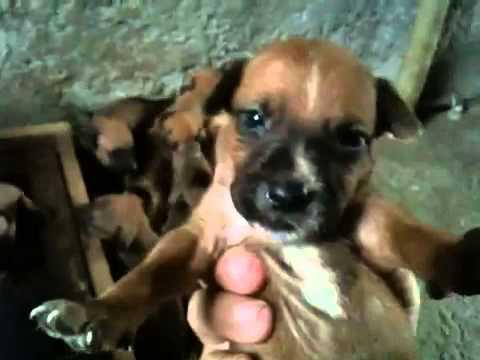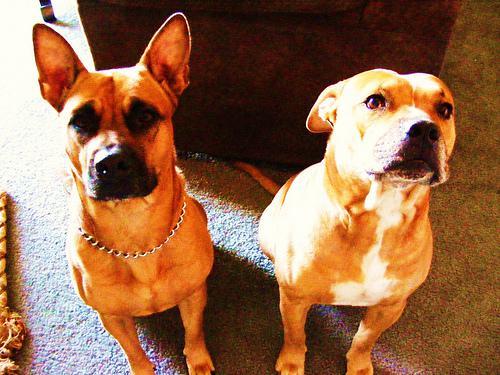The first image is the image on the left, the second image is the image on the right. For the images displayed, is the sentence "Left image contains one tan adult dog wearing a collar." factually correct? Answer yes or no. No. 